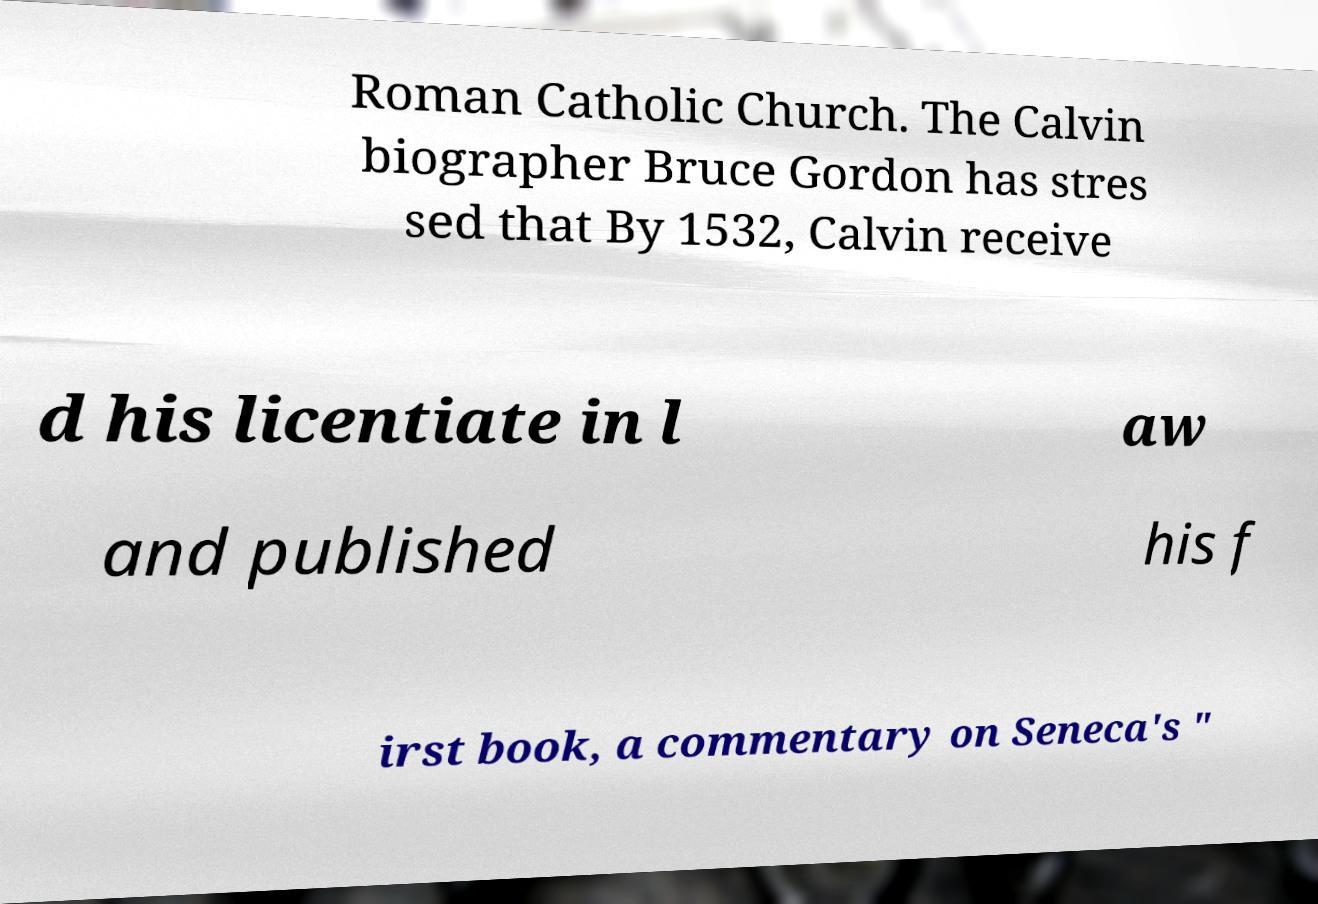Could you assist in decoding the text presented in this image and type it out clearly? Roman Catholic Church. The Calvin biographer Bruce Gordon has stres sed that By 1532, Calvin receive d his licentiate in l aw and published his f irst book, a commentary on Seneca's " 